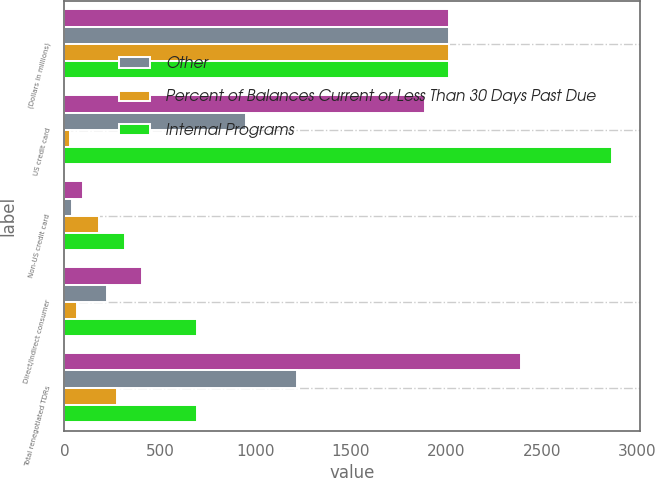<chart> <loc_0><loc_0><loc_500><loc_500><stacked_bar_chart><ecel><fcel>(Dollars in millions)<fcel>US credit card<fcel>Non-US credit card<fcel>Direct/Indirect consumer<fcel>Total renegotiated TDRs<nl><fcel>nan<fcel>2012<fcel>1887<fcel>99<fcel>405<fcel>2391<nl><fcel>Other<fcel>2012<fcel>953<fcel>38<fcel>225<fcel>1216<nl><fcel>Percent of Balances Current or Less Than 30 Days Past Due<fcel>2012<fcel>31<fcel>179<fcel>64<fcel>274<nl><fcel>Internal Programs<fcel>2012<fcel>2871<fcel>316<fcel>694<fcel>694<nl></chart> 